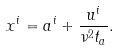<formula> <loc_0><loc_0><loc_500><loc_500>x ^ { i } = a ^ { i } + \frac { u ^ { i } } { \nu ^ { 2 } t _ { a } } .</formula> 